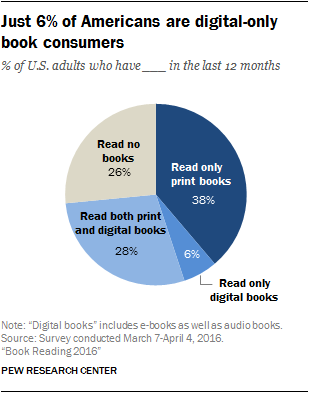Specify some key components in this picture. What is the total amount of all the segments whose value is below 30? There are 3 segments with blue color shades. 